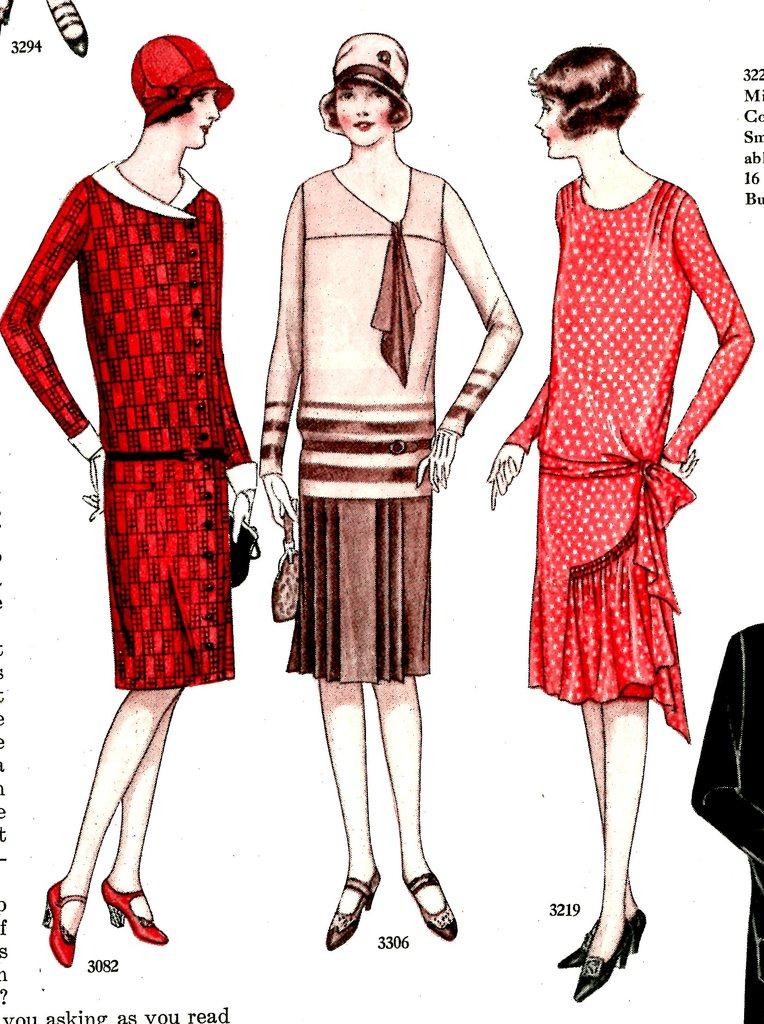What is shown in the image involving people? There is a depiction of persons in the image. Can you describe any other elements in the image besides the people? Yes, there is text present in the image. Can you describe the sidewalk in the image? There is no sidewalk present in the image; it only depicts persons and text. 